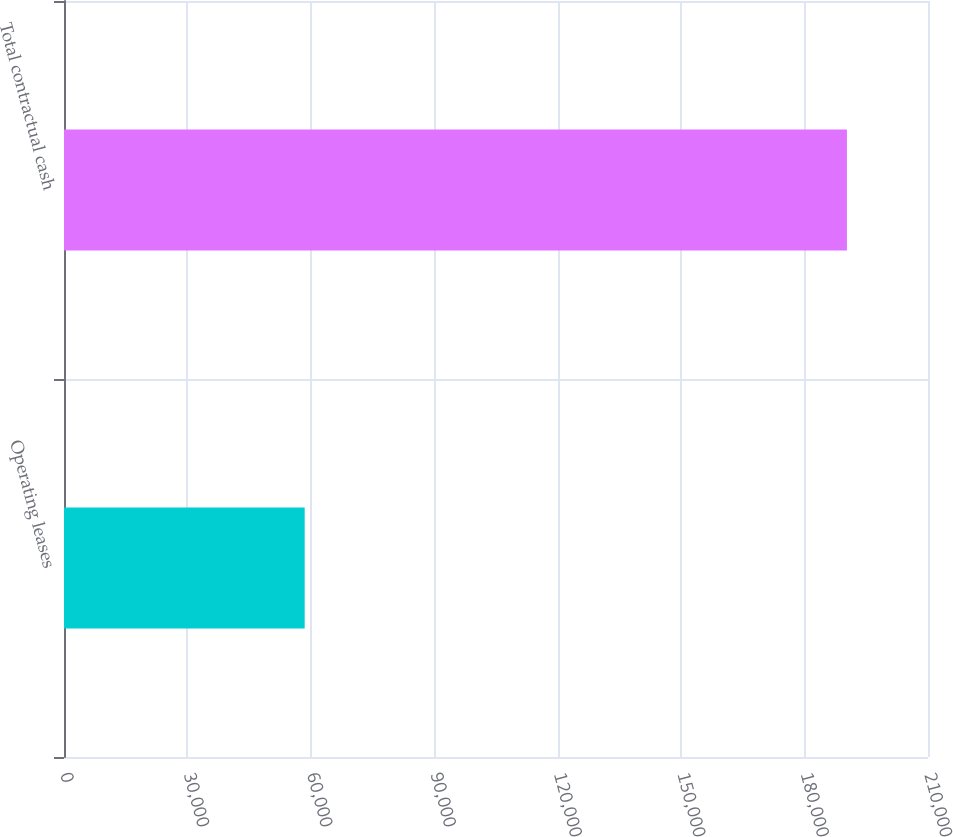<chart> <loc_0><loc_0><loc_500><loc_500><bar_chart><fcel>Operating leases<fcel>Total contractual cash<nl><fcel>58502<fcel>190295<nl></chart> 